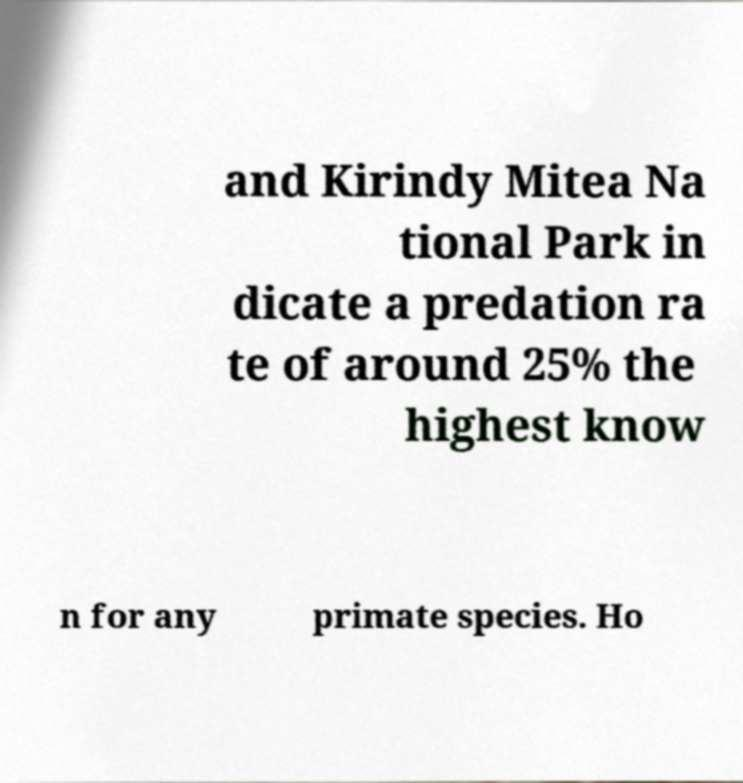Could you assist in decoding the text presented in this image and type it out clearly? and Kirindy Mitea Na tional Park in dicate a predation ra te of around 25% the highest know n for any primate species. Ho 